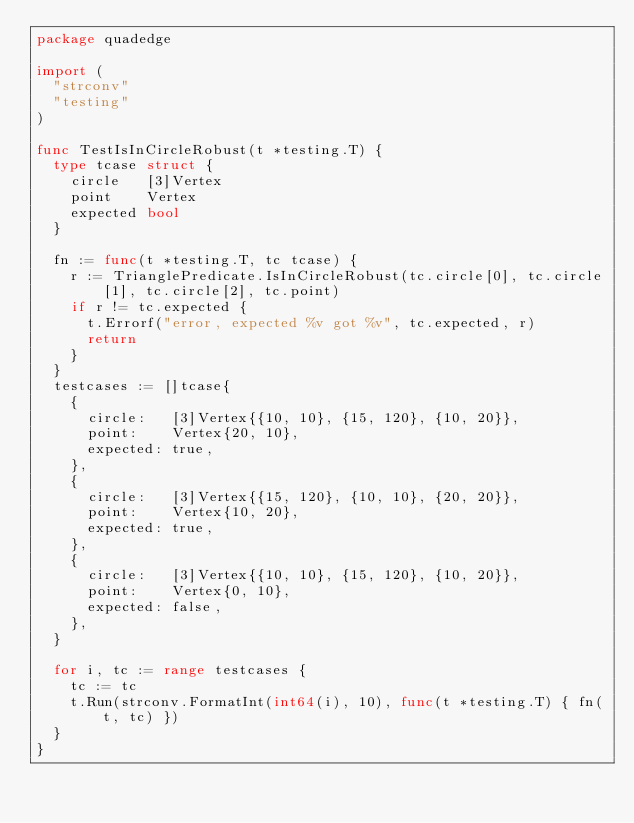<code> <loc_0><loc_0><loc_500><loc_500><_Go_>package quadedge

import (
	"strconv"
	"testing"
)

func TestIsInCircleRobust(t *testing.T) {
	type tcase struct {
		circle   [3]Vertex
		point    Vertex
		expected bool
	}

	fn := func(t *testing.T, tc tcase) {
		r := TrianglePredicate.IsInCircleRobust(tc.circle[0], tc.circle[1], tc.circle[2], tc.point)
		if r != tc.expected {
			t.Errorf("error, expected %v got %v", tc.expected, r)
			return
		}
	}
	testcases := []tcase{
		{
			circle:   [3]Vertex{{10, 10}, {15, 120}, {10, 20}},
			point:    Vertex{20, 10},
			expected: true,
		},
		{
			circle:   [3]Vertex{{15, 120}, {10, 10}, {20, 20}},
			point:    Vertex{10, 20},
			expected: true,
		},
		{
			circle:   [3]Vertex{{10, 10}, {15, 120}, {10, 20}},
			point:    Vertex{0, 10},
			expected: false,
		},
	}

	for i, tc := range testcases {
		tc := tc
		t.Run(strconv.FormatInt(int64(i), 10), func(t *testing.T) { fn(t, tc) })
	}
}
</code> 